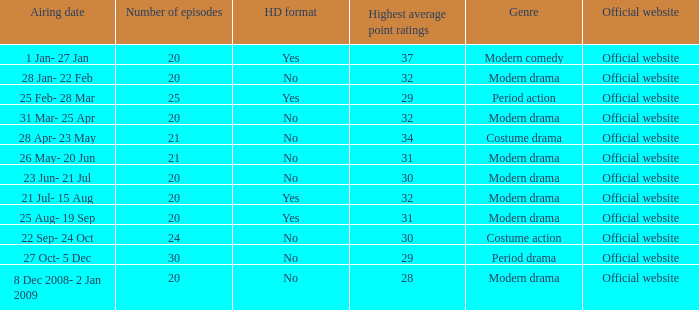When did a costume action show with over 20 episodes have its airing date? 22 Sep- 24 Oct. 